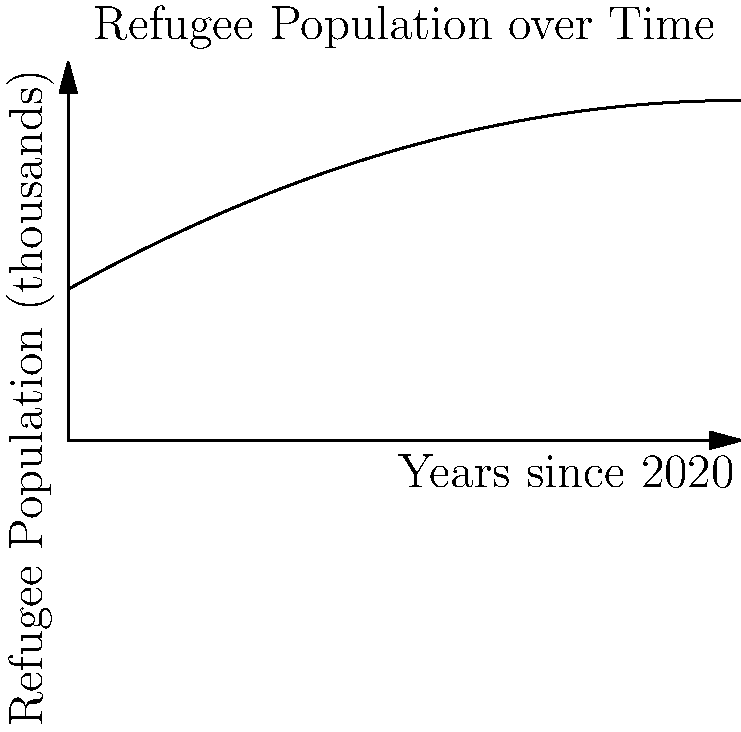The graph shows the refugee population (in thousands) in a region where Angelina Jolie has been doing humanitarian work, as a function of years since 2020. If the population is modeled by the function $P(t) = 2000 + 500t - 25t^2$, where $t$ is the time in years since 2020, at what point in time will the rate of change in the refugee population be zero? To find when the rate of change in the refugee population is zero, we need to follow these steps:

1) The rate of change is given by the derivative of the function $P(t)$.

2) Let's find the derivative:
   $P'(t) = 500 - 50t$

3) We want to find when $P'(t) = 0$:
   $500 - 50t = 0$

4) Solve this equation:
   $-50t = -500$
   $t = 10$

5) This means that after 10 years from 2020 (i.e., in 2030), the rate of change of the refugee population will be zero.

6) We can verify this by looking at the graph. The curve reaches its peak at $t = 10$, which is where the rate of change (slope of the tangent line) is zero.
Answer: 10 years after 2020 (in 2030) 